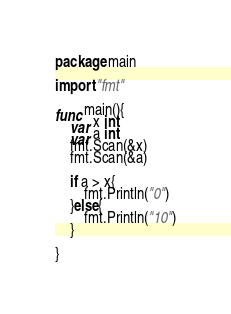<code> <loc_0><loc_0><loc_500><loc_500><_Go_>package main

import "fmt"

func main(){
	var x int
	var a int
	fmt.Scan(&x)
	fmt.Scan(&a)

    if a > x{
    	fmt.Println("0")
	}else{
		fmt.Println("10")
	}

}</code> 